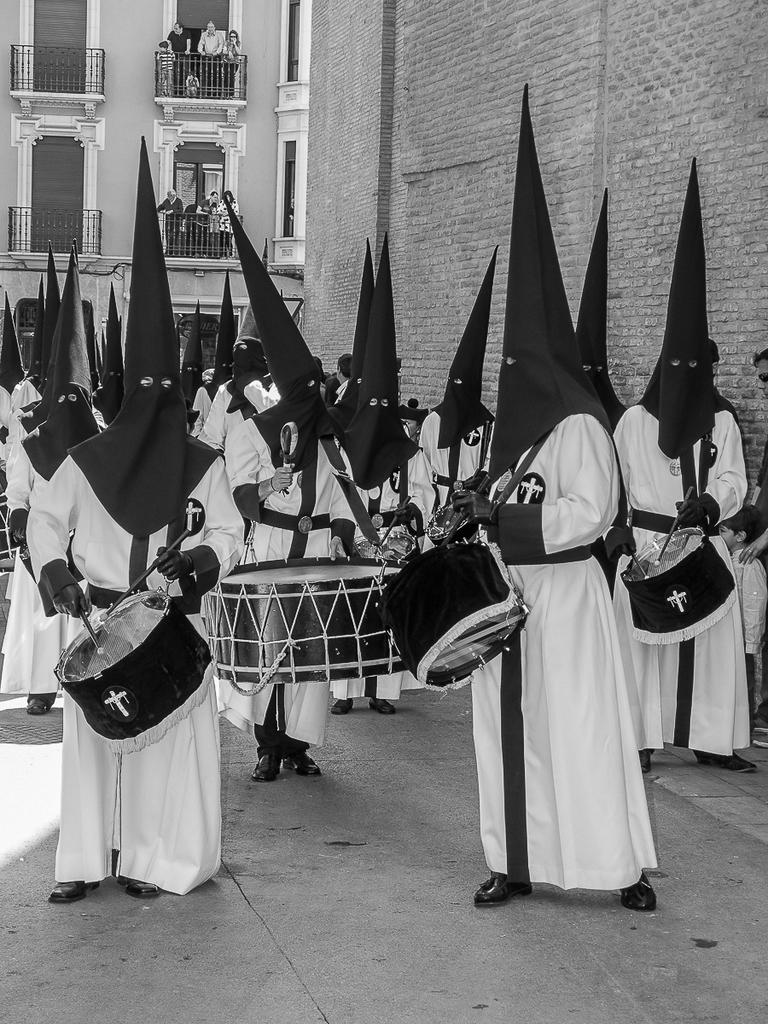What is the main subject of the image? The main subject of the image is a group of people. What are the people wearing in the image? The people are wearing white dresses and black masks. What are the people holding in their hands? The people are holding drums in their hands. What can be seen in the background of the image? There are buildings beside and behind the group of people. What type of rifle can be seen in the hands of the people in the image? There are no rifles present in the image; the people are holding drums. Is there a doctor among the group of people in the image? There is no indication of a doctor or any medical professional in the image. 